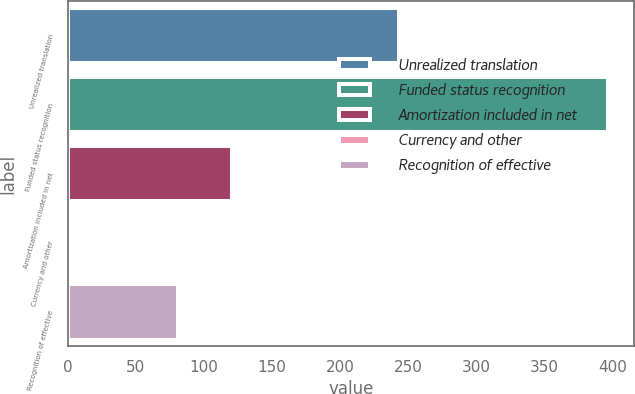Convert chart to OTSL. <chart><loc_0><loc_0><loc_500><loc_500><bar_chart><fcel>Unrealized translation<fcel>Funded status recognition<fcel>Amortization included in net<fcel>Currency and other<fcel>Recognition of effective<nl><fcel>243<fcel>396<fcel>120.4<fcel>2<fcel>81<nl></chart> 